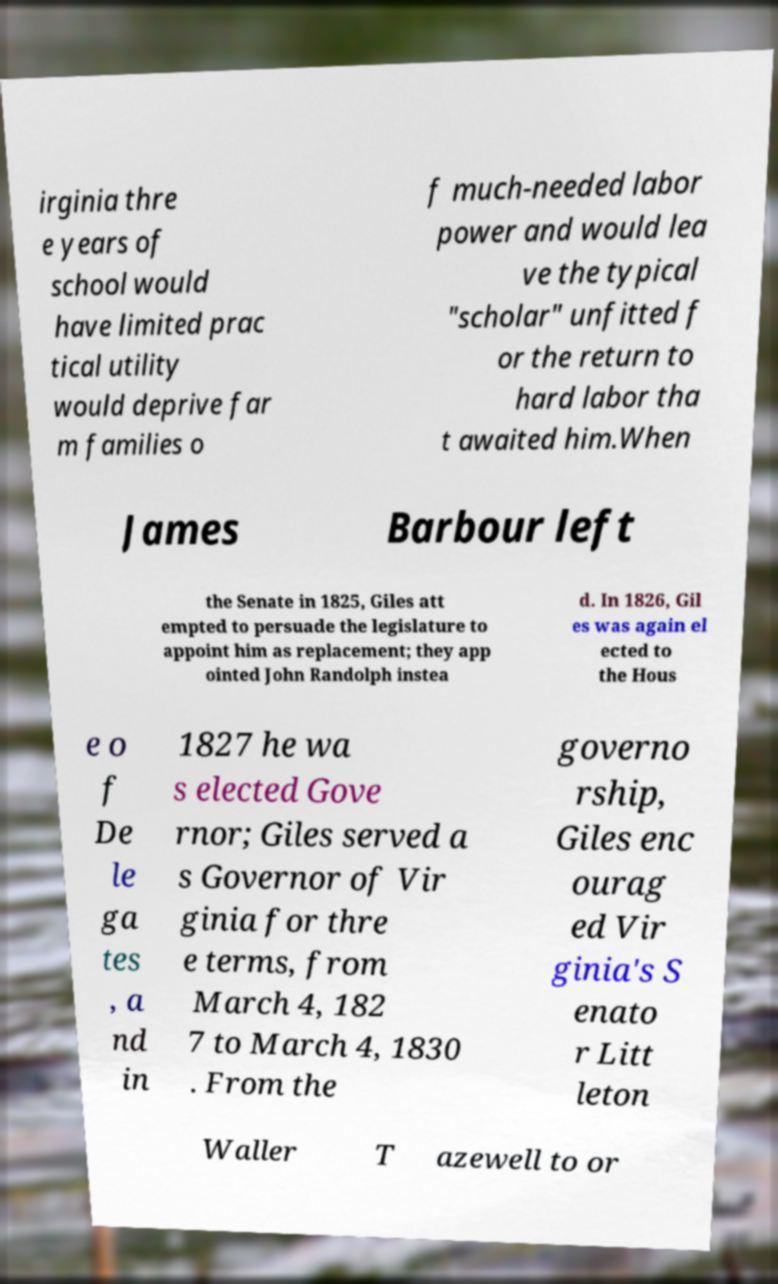I need the written content from this picture converted into text. Can you do that? irginia thre e years of school would have limited prac tical utility would deprive far m families o f much-needed labor power and would lea ve the typical "scholar" unfitted f or the return to hard labor tha t awaited him.When James Barbour left the Senate in 1825, Giles att empted to persuade the legislature to appoint him as replacement; they app ointed John Randolph instea d. In 1826, Gil es was again el ected to the Hous e o f De le ga tes , a nd in 1827 he wa s elected Gove rnor; Giles served a s Governor of Vir ginia for thre e terms, from March 4, 182 7 to March 4, 1830 . From the governo rship, Giles enc ourag ed Vir ginia's S enato r Litt leton Waller T azewell to or 